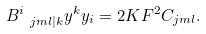Convert formula to latex. <formula><loc_0><loc_0><loc_500><loc_500>B ^ { i } _ { \ j m l | k } y ^ { k } y _ { i } = 2 { K } F ^ { 2 } C _ { j m l } .</formula> 